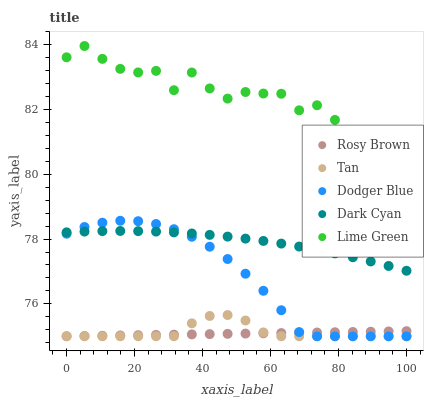Does Rosy Brown have the minimum area under the curve?
Answer yes or no. Yes. Does Lime Green have the maximum area under the curve?
Answer yes or no. Yes. Does Tan have the minimum area under the curve?
Answer yes or no. No. Does Tan have the maximum area under the curve?
Answer yes or no. No. Is Rosy Brown the smoothest?
Answer yes or no. Yes. Is Lime Green the roughest?
Answer yes or no. Yes. Is Tan the smoothest?
Answer yes or no. No. Is Tan the roughest?
Answer yes or no. No. Does Tan have the lowest value?
Answer yes or no. Yes. Does Lime Green have the lowest value?
Answer yes or no. No. Does Lime Green have the highest value?
Answer yes or no. Yes. Does Tan have the highest value?
Answer yes or no. No. Is Tan less than Lime Green?
Answer yes or no. Yes. Is Lime Green greater than Dodger Blue?
Answer yes or no. Yes. Does Tan intersect Dodger Blue?
Answer yes or no. Yes. Is Tan less than Dodger Blue?
Answer yes or no. No. Is Tan greater than Dodger Blue?
Answer yes or no. No. Does Tan intersect Lime Green?
Answer yes or no. No. 